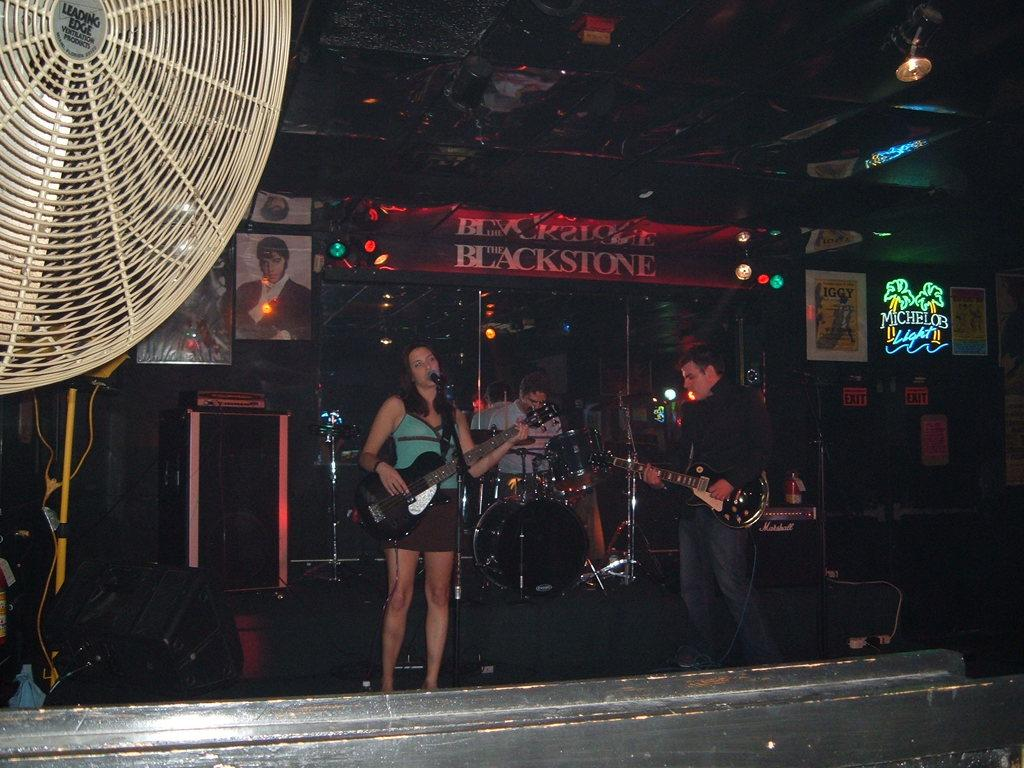Who are the people in the image? There is a woman and a man in the image. What are they doing in the image? Both the woman and the man are playing a guitar. What is the position of the man in the image? The man is sitting while playing the musical instrument. What can be seen on the wall in the image? There are posters and photos on the wall. What is the source of light visible in the image? There is a light visible at the top of the image. What type of door can be seen in the image? There is no door visible in the image. What design is featured on the guitar being played by the woman? The image does not provide enough detail to determine the design on the guitar being played by the woman. 